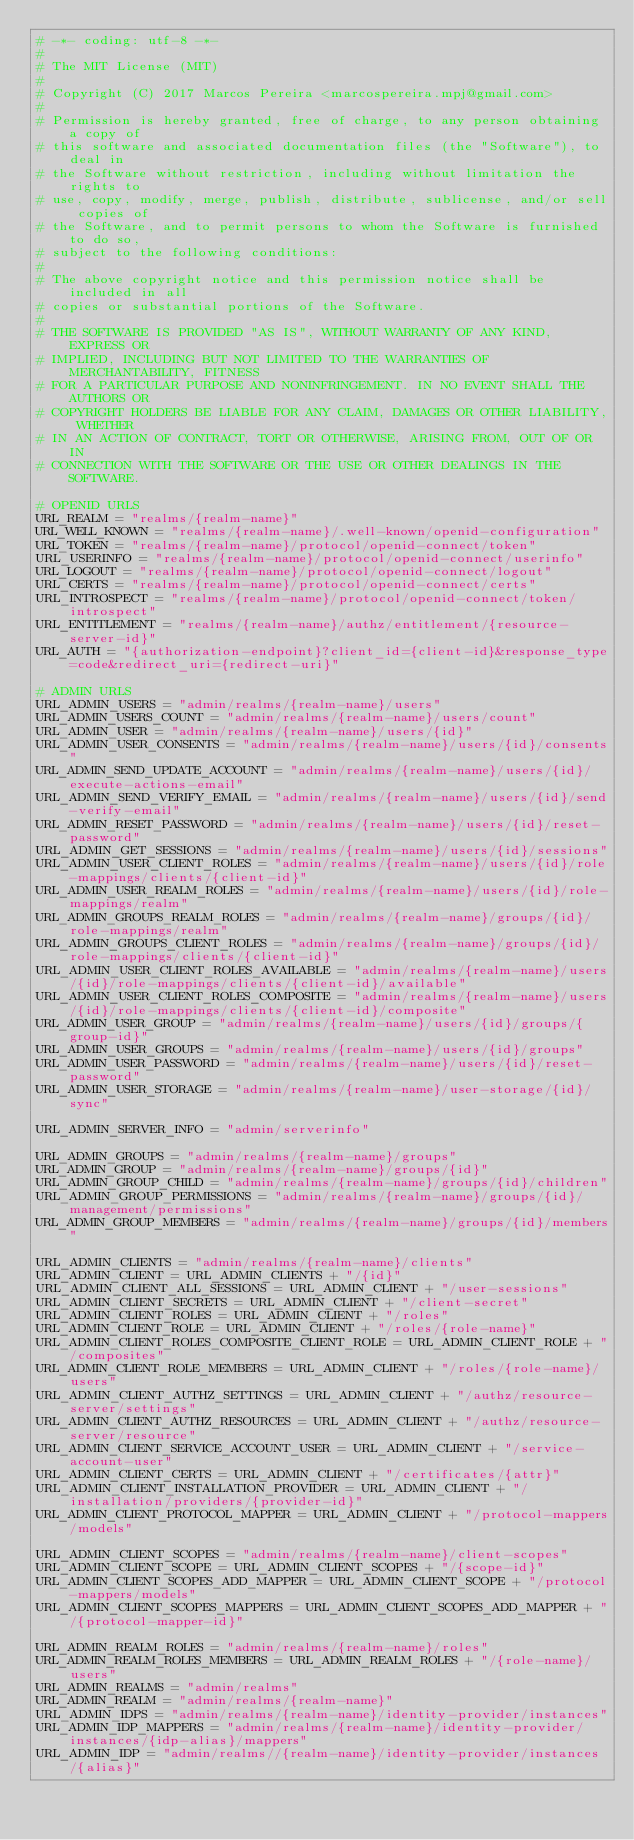<code> <loc_0><loc_0><loc_500><loc_500><_Python_># -*- coding: utf-8 -*-
#
# The MIT License (MIT)
#
# Copyright (C) 2017 Marcos Pereira <marcospereira.mpj@gmail.com>
#
# Permission is hereby granted, free of charge, to any person obtaining a copy of
# this software and associated documentation files (the "Software"), to deal in
# the Software without restriction, including without limitation the rights to
# use, copy, modify, merge, publish, distribute, sublicense, and/or sell copies of
# the Software, and to permit persons to whom the Software is furnished to do so,
# subject to the following conditions:
#
# The above copyright notice and this permission notice shall be included in all
# copies or substantial portions of the Software.
#
# THE SOFTWARE IS PROVIDED "AS IS", WITHOUT WARRANTY OF ANY KIND, EXPRESS OR
# IMPLIED, INCLUDING BUT NOT LIMITED TO THE WARRANTIES OF MERCHANTABILITY, FITNESS
# FOR A PARTICULAR PURPOSE AND NONINFRINGEMENT. IN NO EVENT SHALL THE AUTHORS OR
# COPYRIGHT HOLDERS BE LIABLE FOR ANY CLAIM, DAMAGES OR OTHER LIABILITY, WHETHER
# IN AN ACTION OF CONTRACT, TORT OR OTHERWISE, ARISING FROM, OUT OF OR IN
# CONNECTION WITH THE SOFTWARE OR THE USE OR OTHER DEALINGS IN THE SOFTWARE.

# OPENID URLS
URL_REALM = "realms/{realm-name}"
URL_WELL_KNOWN = "realms/{realm-name}/.well-known/openid-configuration"
URL_TOKEN = "realms/{realm-name}/protocol/openid-connect/token"
URL_USERINFO = "realms/{realm-name}/protocol/openid-connect/userinfo"
URL_LOGOUT = "realms/{realm-name}/protocol/openid-connect/logout"
URL_CERTS = "realms/{realm-name}/protocol/openid-connect/certs"
URL_INTROSPECT = "realms/{realm-name}/protocol/openid-connect/token/introspect"
URL_ENTITLEMENT = "realms/{realm-name}/authz/entitlement/{resource-server-id}"
URL_AUTH = "{authorization-endpoint}?client_id={client-id}&response_type=code&redirect_uri={redirect-uri}"

# ADMIN URLS
URL_ADMIN_USERS = "admin/realms/{realm-name}/users"
URL_ADMIN_USERS_COUNT = "admin/realms/{realm-name}/users/count"
URL_ADMIN_USER = "admin/realms/{realm-name}/users/{id}"
URL_ADMIN_USER_CONSENTS = "admin/realms/{realm-name}/users/{id}/consents"
URL_ADMIN_SEND_UPDATE_ACCOUNT = "admin/realms/{realm-name}/users/{id}/execute-actions-email"
URL_ADMIN_SEND_VERIFY_EMAIL = "admin/realms/{realm-name}/users/{id}/send-verify-email"
URL_ADMIN_RESET_PASSWORD = "admin/realms/{realm-name}/users/{id}/reset-password"
URL_ADMIN_GET_SESSIONS = "admin/realms/{realm-name}/users/{id}/sessions"
URL_ADMIN_USER_CLIENT_ROLES = "admin/realms/{realm-name}/users/{id}/role-mappings/clients/{client-id}"
URL_ADMIN_USER_REALM_ROLES = "admin/realms/{realm-name}/users/{id}/role-mappings/realm"
URL_ADMIN_GROUPS_REALM_ROLES = "admin/realms/{realm-name}/groups/{id}/role-mappings/realm"
URL_ADMIN_GROUPS_CLIENT_ROLES = "admin/realms/{realm-name}/groups/{id}/role-mappings/clients/{client-id}"
URL_ADMIN_USER_CLIENT_ROLES_AVAILABLE = "admin/realms/{realm-name}/users/{id}/role-mappings/clients/{client-id}/available"
URL_ADMIN_USER_CLIENT_ROLES_COMPOSITE = "admin/realms/{realm-name}/users/{id}/role-mappings/clients/{client-id}/composite"
URL_ADMIN_USER_GROUP = "admin/realms/{realm-name}/users/{id}/groups/{group-id}"
URL_ADMIN_USER_GROUPS = "admin/realms/{realm-name}/users/{id}/groups"
URL_ADMIN_USER_PASSWORD = "admin/realms/{realm-name}/users/{id}/reset-password"
URL_ADMIN_USER_STORAGE = "admin/realms/{realm-name}/user-storage/{id}/sync"

URL_ADMIN_SERVER_INFO = "admin/serverinfo"

URL_ADMIN_GROUPS = "admin/realms/{realm-name}/groups"
URL_ADMIN_GROUP = "admin/realms/{realm-name}/groups/{id}"
URL_ADMIN_GROUP_CHILD = "admin/realms/{realm-name}/groups/{id}/children"
URL_ADMIN_GROUP_PERMISSIONS = "admin/realms/{realm-name}/groups/{id}/management/permissions"
URL_ADMIN_GROUP_MEMBERS = "admin/realms/{realm-name}/groups/{id}/members"

URL_ADMIN_CLIENTS = "admin/realms/{realm-name}/clients"
URL_ADMIN_CLIENT = URL_ADMIN_CLIENTS + "/{id}"
URL_ADMIN_CLIENT_ALL_SESSIONS = URL_ADMIN_CLIENT + "/user-sessions"
URL_ADMIN_CLIENT_SECRETS = URL_ADMIN_CLIENT + "/client-secret"
URL_ADMIN_CLIENT_ROLES = URL_ADMIN_CLIENT + "/roles"
URL_ADMIN_CLIENT_ROLE = URL_ADMIN_CLIENT + "/roles/{role-name}"
URL_ADMIN_CLIENT_ROLES_COMPOSITE_CLIENT_ROLE = URL_ADMIN_CLIENT_ROLE + "/composites"
URL_ADMIN_CLIENT_ROLE_MEMBERS = URL_ADMIN_CLIENT + "/roles/{role-name}/users"
URL_ADMIN_CLIENT_AUTHZ_SETTINGS = URL_ADMIN_CLIENT + "/authz/resource-server/settings"
URL_ADMIN_CLIENT_AUTHZ_RESOURCES = URL_ADMIN_CLIENT + "/authz/resource-server/resource"
URL_ADMIN_CLIENT_SERVICE_ACCOUNT_USER = URL_ADMIN_CLIENT + "/service-account-user"
URL_ADMIN_CLIENT_CERTS = URL_ADMIN_CLIENT + "/certificates/{attr}"
URL_ADMIN_CLIENT_INSTALLATION_PROVIDER = URL_ADMIN_CLIENT + "/installation/providers/{provider-id}"
URL_ADMIN_CLIENT_PROTOCOL_MAPPER = URL_ADMIN_CLIENT + "/protocol-mappers/models"

URL_ADMIN_CLIENT_SCOPES = "admin/realms/{realm-name}/client-scopes"
URL_ADMIN_CLIENT_SCOPE = URL_ADMIN_CLIENT_SCOPES + "/{scope-id}"
URL_ADMIN_CLIENT_SCOPES_ADD_MAPPER = URL_ADMIN_CLIENT_SCOPE + "/protocol-mappers/models"
URL_ADMIN_CLIENT_SCOPES_MAPPERS = URL_ADMIN_CLIENT_SCOPES_ADD_MAPPER + "/{protocol-mapper-id}"

URL_ADMIN_REALM_ROLES = "admin/realms/{realm-name}/roles"
URL_ADMIN_REALM_ROLES_MEMBERS = URL_ADMIN_REALM_ROLES + "/{role-name}/users"
URL_ADMIN_REALMS = "admin/realms"
URL_ADMIN_REALM = "admin/realms/{realm-name}"
URL_ADMIN_IDPS = "admin/realms/{realm-name}/identity-provider/instances"
URL_ADMIN_IDP_MAPPERS = "admin/realms/{realm-name}/identity-provider/instances/{idp-alias}/mappers"
URL_ADMIN_IDP = "admin/realms//{realm-name}/identity-provider/instances/{alias}"</code> 